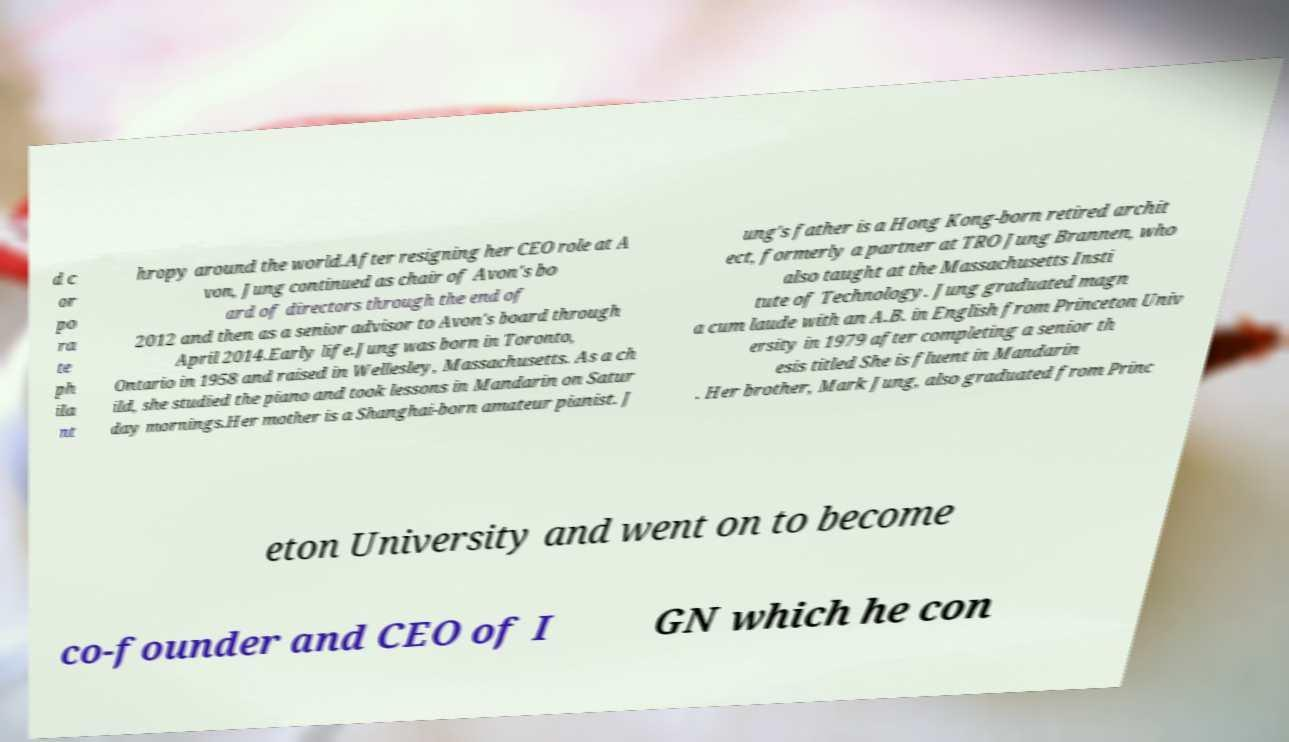There's text embedded in this image that I need extracted. Can you transcribe it verbatim? d c or po ra te ph ila nt hropy around the world.After resigning her CEO role at A von, Jung continued as chair of Avon's bo ard of directors through the end of 2012 and then as a senior advisor to Avon's board through April 2014.Early life.Jung was born in Toronto, Ontario in 1958 and raised in Wellesley, Massachusetts. As a ch ild, she studied the piano and took lessons in Mandarin on Satur day mornings.Her mother is a Shanghai-born amateur pianist. J ung's father is a Hong Kong-born retired archit ect, formerly a partner at TRO Jung Brannen, who also taught at the Massachusetts Insti tute of Technology. Jung graduated magn a cum laude with an A.B. in English from Princeton Univ ersity in 1979 after completing a senior th esis titled She is fluent in Mandarin . Her brother, Mark Jung, also graduated from Princ eton University and went on to become co-founder and CEO of I GN which he con 